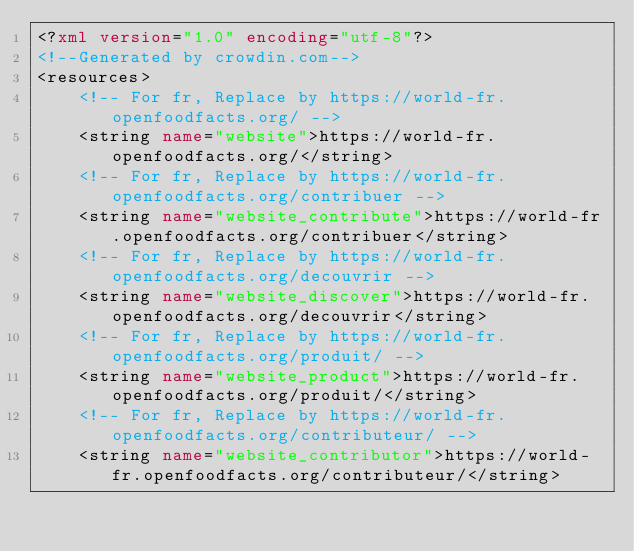Convert code to text. <code><loc_0><loc_0><loc_500><loc_500><_XML_><?xml version="1.0" encoding="utf-8"?>
<!--Generated by crowdin.com-->
<resources>
    <!-- For fr, Replace by https://world-fr.openfoodfacts.org/ -->
    <string name="website">https://world-fr.openfoodfacts.org/</string>
    <!-- For fr, Replace by https://world-fr.openfoodfacts.org/contribuer -->
    <string name="website_contribute">https://world-fr.openfoodfacts.org/contribuer</string>
    <!-- For fr, Replace by https://world-fr.openfoodfacts.org/decouvrir -->
    <string name="website_discover">https://world-fr.openfoodfacts.org/decouvrir</string>
    <!-- For fr, Replace by https://world-fr.openfoodfacts.org/produit/ -->
    <string name="website_product">https://world-fr.openfoodfacts.org/produit/</string>
    <!-- For fr, Replace by https://world-fr.openfoodfacts.org/contributeur/ -->
    <string name="website_contributor">https://world-fr.openfoodfacts.org/contributeur/</string></code> 